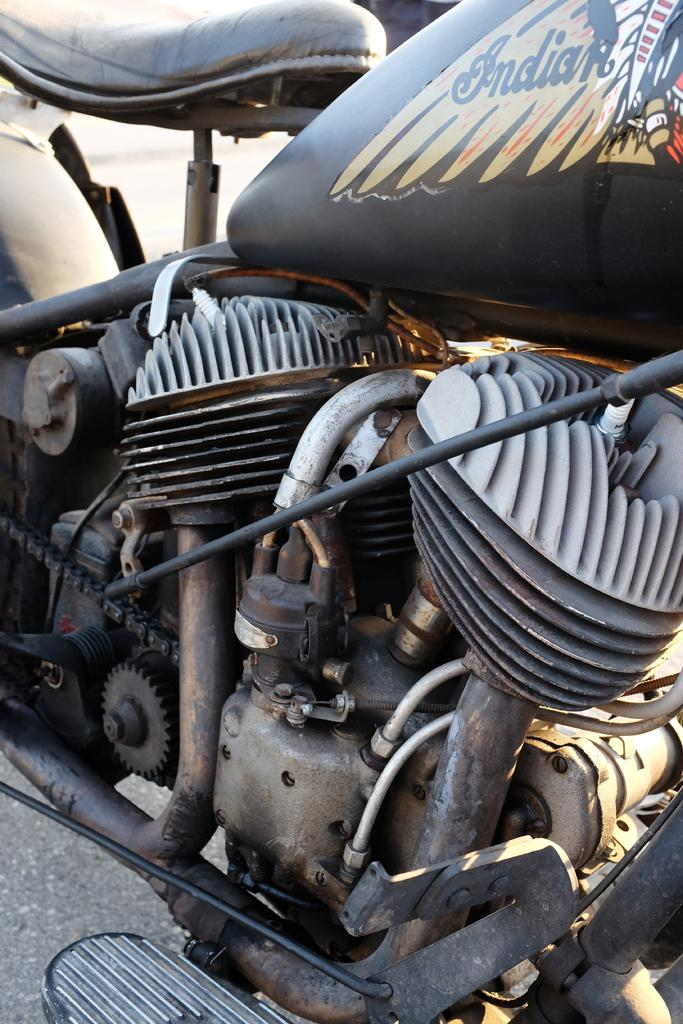What is the main subject of the image? The main subject of the image is a bike. Where is the bike located in the image? The bike is on the road. Is there a basket on the bike in the image? There is no mention of a basket on the bike in the provided facts, so we cannot determine its presence from the image. 